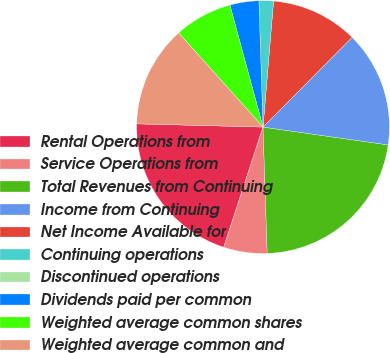Convert chart. <chart><loc_0><loc_0><loc_500><loc_500><pie_chart><fcel>Rental Operations from<fcel>Service Operations from<fcel>Total Revenues from Continuing<fcel>Income from Continuing<fcel>Net Income Available for<fcel>Continuing operations<fcel>Discontinued operations<fcel>Dividends paid per common<fcel>Weighted average common shares<fcel>Weighted average common and<nl><fcel>20.37%<fcel>5.56%<fcel>22.22%<fcel>14.81%<fcel>11.11%<fcel>1.85%<fcel>0.0%<fcel>3.7%<fcel>7.41%<fcel>12.96%<nl></chart> 